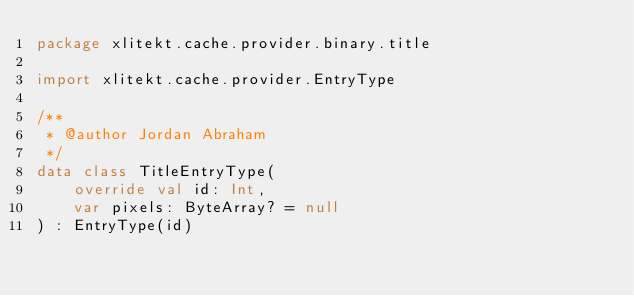<code> <loc_0><loc_0><loc_500><loc_500><_Kotlin_>package xlitekt.cache.provider.binary.title

import xlitekt.cache.provider.EntryType

/**
 * @author Jordan Abraham
 */
data class TitleEntryType(
    override val id: Int,
    var pixels: ByteArray? = null
) : EntryType(id)
</code> 